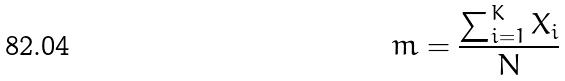<formula> <loc_0><loc_0><loc_500><loc_500>m = \frac { \sum _ { i = 1 } ^ { K } X _ { i } } { N }</formula> 